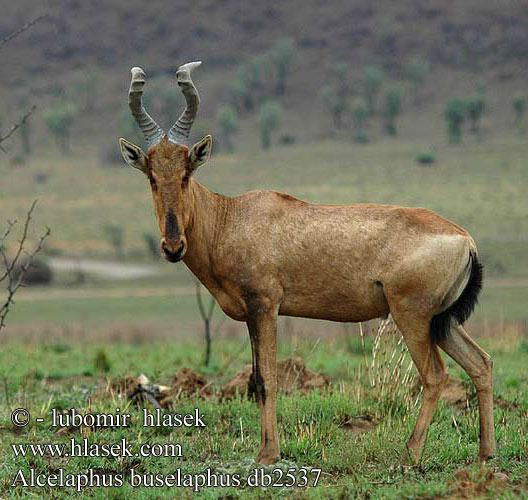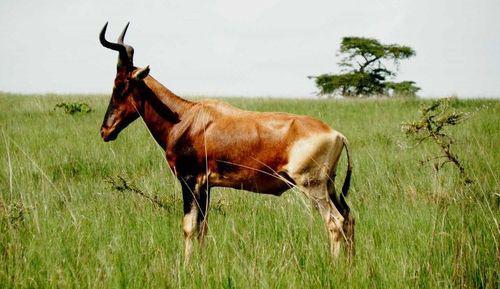The first image is the image on the left, the second image is the image on the right. Assess this claim about the two images: "One of the images features an animal facing left with it's head turned straight.". Correct or not? Answer yes or no. Yes. The first image is the image on the left, the second image is the image on the right. For the images displayed, is the sentence "There is a whole heard of antelope in both of the images." factually correct? Answer yes or no. No. 